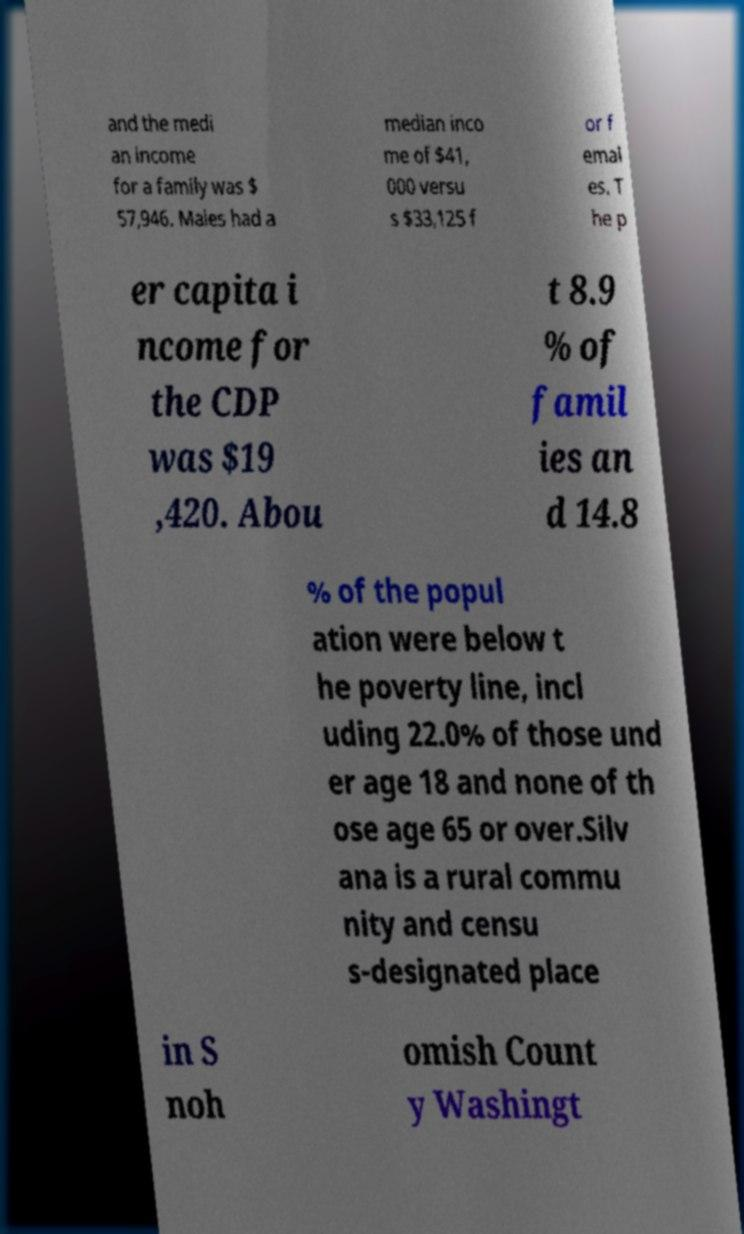Please identify and transcribe the text found in this image. and the medi an income for a family was $ 57,946. Males had a median inco me of $41, 000 versu s $33,125 f or f emal es. T he p er capita i ncome for the CDP was $19 ,420. Abou t 8.9 % of famil ies an d 14.8 % of the popul ation were below t he poverty line, incl uding 22.0% of those und er age 18 and none of th ose age 65 or over.Silv ana is a rural commu nity and censu s-designated place in S noh omish Count y Washingt 